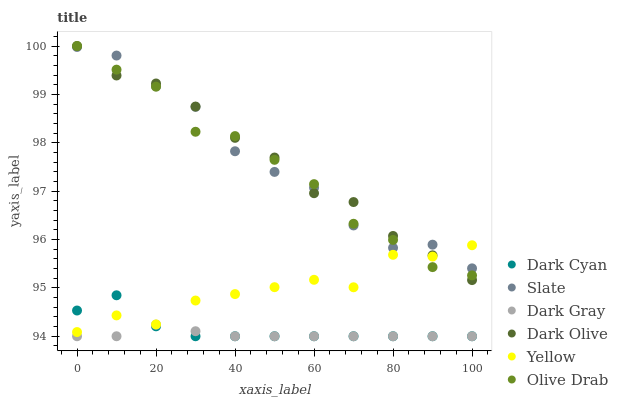Does Dark Gray have the minimum area under the curve?
Answer yes or no. Yes. Does Dark Olive have the maximum area under the curve?
Answer yes or no. Yes. Does Yellow have the minimum area under the curve?
Answer yes or no. No. Does Yellow have the maximum area under the curve?
Answer yes or no. No. Is Dark Gray the smoothest?
Answer yes or no. Yes. Is Yellow the roughest?
Answer yes or no. Yes. Is Dark Olive the smoothest?
Answer yes or no. No. Is Dark Olive the roughest?
Answer yes or no. No. Does Dark Gray have the lowest value?
Answer yes or no. Yes. Does Dark Olive have the lowest value?
Answer yes or no. No. Does Olive Drab have the highest value?
Answer yes or no. Yes. Does Yellow have the highest value?
Answer yes or no. No. Is Dark Cyan less than Dark Olive?
Answer yes or no. Yes. Is Slate greater than Dark Gray?
Answer yes or no. Yes. Does Yellow intersect Slate?
Answer yes or no. Yes. Is Yellow less than Slate?
Answer yes or no. No. Is Yellow greater than Slate?
Answer yes or no. No. Does Dark Cyan intersect Dark Olive?
Answer yes or no. No. 